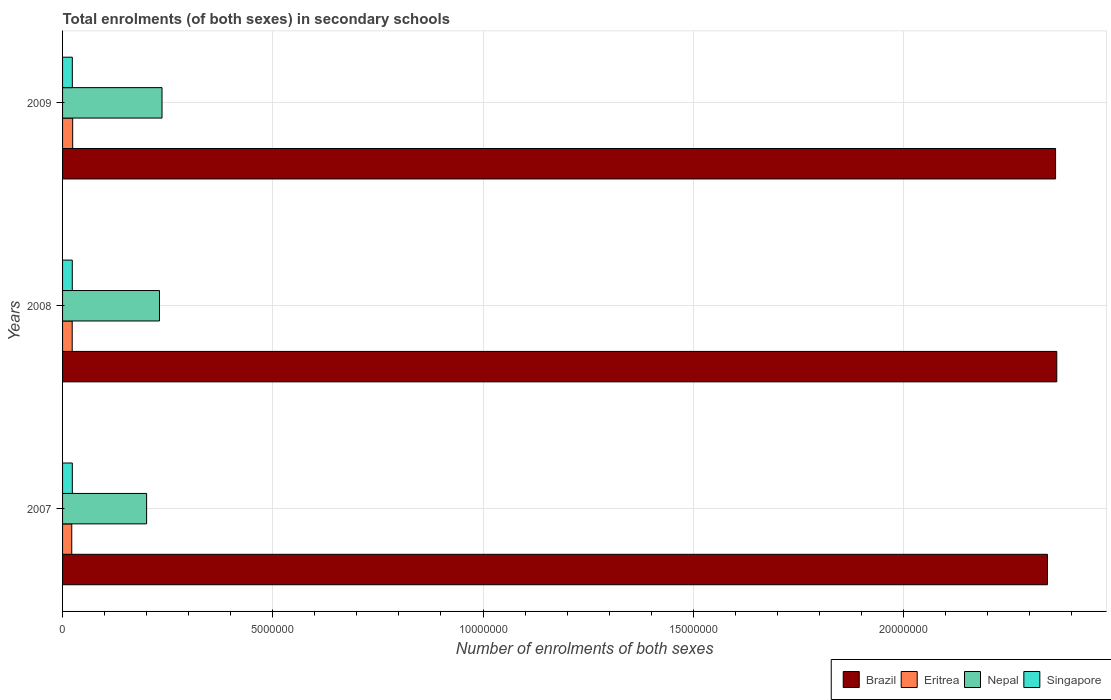How many different coloured bars are there?
Ensure brevity in your answer.  4. How many groups of bars are there?
Provide a succinct answer. 3. Are the number of bars on each tick of the Y-axis equal?
Offer a very short reply. Yes. How many bars are there on the 3rd tick from the top?
Make the answer very short. 4. What is the number of enrolments in secondary schools in Brazil in 2009?
Ensure brevity in your answer.  2.36e+07. Across all years, what is the maximum number of enrolments in secondary schools in Eritrea?
Offer a very short reply. 2.41e+05. Across all years, what is the minimum number of enrolments in secondary schools in Eritrea?
Offer a very short reply. 2.18e+05. In which year was the number of enrolments in secondary schools in Nepal maximum?
Your answer should be very brief. 2009. What is the total number of enrolments in secondary schools in Brazil in the graph?
Provide a short and direct response. 7.07e+07. What is the difference between the number of enrolments in secondary schools in Eritrea in 2008 and that in 2009?
Ensure brevity in your answer.  -1.18e+04. What is the difference between the number of enrolments in secondary schools in Brazil in 2009 and the number of enrolments in secondary schools in Singapore in 2008?
Give a very brief answer. 2.34e+07. What is the average number of enrolments in secondary schools in Singapore per year?
Your response must be concise. 2.32e+05. In the year 2009, what is the difference between the number of enrolments in secondary schools in Nepal and number of enrolments in secondary schools in Brazil?
Ensure brevity in your answer.  -2.13e+07. In how many years, is the number of enrolments in secondary schools in Eritrea greater than 6000000 ?
Make the answer very short. 0. What is the ratio of the number of enrolments in secondary schools in Eritrea in 2007 to that in 2009?
Your answer should be very brief. 0.91. Is the number of enrolments in secondary schools in Brazil in 2007 less than that in 2009?
Provide a succinct answer. Yes. Is the difference between the number of enrolments in secondary schools in Nepal in 2007 and 2008 greater than the difference between the number of enrolments in secondary schools in Brazil in 2007 and 2008?
Give a very brief answer. No. What is the difference between the highest and the second highest number of enrolments in secondary schools in Brazil?
Keep it short and to the point. 2.87e+04. What is the difference between the highest and the lowest number of enrolments in secondary schools in Eritrea?
Offer a terse response. 2.25e+04. Is it the case that in every year, the sum of the number of enrolments in secondary schools in Eritrea and number of enrolments in secondary schools in Brazil is greater than the sum of number of enrolments in secondary schools in Singapore and number of enrolments in secondary schools in Nepal?
Provide a succinct answer. No. What does the 2nd bar from the top in 2007 represents?
Keep it short and to the point. Nepal. What does the 3rd bar from the bottom in 2009 represents?
Ensure brevity in your answer.  Nepal. How many bars are there?
Your response must be concise. 12. Are all the bars in the graph horizontal?
Make the answer very short. Yes. Does the graph contain any zero values?
Provide a succinct answer. No. How many legend labels are there?
Offer a terse response. 4. How are the legend labels stacked?
Give a very brief answer. Horizontal. What is the title of the graph?
Your response must be concise. Total enrolments (of both sexes) in secondary schools. Does "Serbia" appear as one of the legend labels in the graph?
Offer a terse response. No. What is the label or title of the X-axis?
Provide a short and direct response. Number of enrolments of both sexes. What is the label or title of the Y-axis?
Provide a short and direct response. Years. What is the Number of enrolments of both sexes of Brazil in 2007?
Offer a terse response. 2.34e+07. What is the Number of enrolments of both sexes of Eritrea in 2007?
Provide a succinct answer. 2.18e+05. What is the Number of enrolments of both sexes of Nepal in 2007?
Provide a short and direct response. 2.00e+06. What is the Number of enrolments of both sexes in Singapore in 2007?
Provide a succinct answer. 2.32e+05. What is the Number of enrolments of both sexes of Brazil in 2008?
Keep it short and to the point. 2.36e+07. What is the Number of enrolments of both sexes of Eritrea in 2008?
Keep it short and to the point. 2.29e+05. What is the Number of enrolments of both sexes in Nepal in 2008?
Give a very brief answer. 2.31e+06. What is the Number of enrolments of both sexes of Singapore in 2008?
Your answer should be very brief. 2.31e+05. What is the Number of enrolments of both sexes of Brazil in 2009?
Ensure brevity in your answer.  2.36e+07. What is the Number of enrolments of both sexes in Eritrea in 2009?
Your response must be concise. 2.41e+05. What is the Number of enrolments of both sexes of Nepal in 2009?
Offer a very short reply. 2.37e+06. What is the Number of enrolments of both sexes of Singapore in 2009?
Give a very brief answer. 2.32e+05. Across all years, what is the maximum Number of enrolments of both sexes in Brazil?
Ensure brevity in your answer.  2.36e+07. Across all years, what is the maximum Number of enrolments of both sexes in Eritrea?
Your answer should be very brief. 2.41e+05. Across all years, what is the maximum Number of enrolments of both sexes in Nepal?
Provide a short and direct response. 2.37e+06. Across all years, what is the maximum Number of enrolments of both sexes in Singapore?
Offer a terse response. 2.32e+05. Across all years, what is the minimum Number of enrolments of both sexes in Brazil?
Your answer should be very brief. 2.34e+07. Across all years, what is the minimum Number of enrolments of both sexes in Eritrea?
Keep it short and to the point. 2.18e+05. Across all years, what is the minimum Number of enrolments of both sexes of Nepal?
Ensure brevity in your answer.  2.00e+06. Across all years, what is the minimum Number of enrolments of both sexes in Singapore?
Your response must be concise. 2.31e+05. What is the total Number of enrolments of both sexes of Brazil in the graph?
Keep it short and to the point. 7.07e+07. What is the total Number of enrolments of both sexes of Eritrea in the graph?
Your response must be concise. 6.88e+05. What is the total Number of enrolments of both sexes of Nepal in the graph?
Provide a short and direct response. 6.67e+06. What is the total Number of enrolments of both sexes in Singapore in the graph?
Offer a very short reply. 6.95e+05. What is the difference between the Number of enrolments of both sexes of Brazil in 2007 and that in 2008?
Offer a terse response. -2.22e+05. What is the difference between the Number of enrolments of both sexes in Eritrea in 2007 and that in 2008?
Your answer should be compact. -1.07e+04. What is the difference between the Number of enrolments of both sexes in Nepal in 2007 and that in 2008?
Your response must be concise. -3.06e+05. What is the difference between the Number of enrolments of both sexes in Singapore in 2007 and that in 2008?
Keep it short and to the point. 956. What is the difference between the Number of enrolments of both sexes in Brazil in 2007 and that in 2009?
Offer a terse response. -1.93e+05. What is the difference between the Number of enrolments of both sexes of Eritrea in 2007 and that in 2009?
Your answer should be very brief. -2.25e+04. What is the difference between the Number of enrolments of both sexes of Nepal in 2007 and that in 2009?
Give a very brief answer. -3.66e+05. What is the difference between the Number of enrolments of both sexes of Singapore in 2007 and that in 2009?
Provide a short and direct response. 97. What is the difference between the Number of enrolments of both sexes in Brazil in 2008 and that in 2009?
Give a very brief answer. 2.87e+04. What is the difference between the Number of enrolments of both sexes of Eritrea in 2008 and that in 2009?
Your answer should be very brief. -1.18e+04. What is the difference between the Number of enrolments of both sexes of Nepal in 2008 and that in 2009?
Your response must be concise. -6.01e+04. What is the difference between the Number of enrolments of both sexes in Singapore in 2008 and that in 2009?
Give a very brief answer. -859. What is the difference between the Number of enrolments of both sexes of Brazil in 2007 and the Number of enrolments of both sexes of Eritrea in 2008?
Offer a very short reply. 2.32e+07. What is the difference between the Number of enrolments of both sexes of Brazil in 2007 and the Number of enrolments of both sexes of Nepal in 2008?
Provide a short and direct response. 2.11e+07. What is the difference between the Number of enrolments of both sexes of Brazil in 2007 and the Number of enrolments of both sexes of Singapore in 2008?
Make the answer very short. 2.32e+07. What is the difference between the Number of enrolments of both sexes of Eritrea in 2007 and the Number of enrolments of both sexes of Nepal in 2008?
Provide a succinct answer. -2.09e+06. What is the difference between the Number of enrolments of both sexes of Eritrea in 2007 and the Number of enrolments of both sexes of Singapore in 2008?
Your response must be concise. -1.28e+04. What is the difference between the Number of enrolments of both sexes in Nepal in 2007 and the Number of enrolments of both sexes in Singapore in 2008?
Provide a short and direct response. 1.77e+06. What is the difference between the Number of enrolments of both sexes in Brazil in 2007 and the Number of enrolments of both sexes in Eritrea in 2009?
Make the answer very short. 2.32e+07. What is the difference between the Number of enrolments of both sexes in Brazil in 2007 and the Number of enrolments of both sexes in Nepal in 2009?
Your response must be concise. 2.11e+07. What is the difference between the Number of enrolments of both sexes of Brazil in 2007 and the Number of enrolments of both sexes of Singapore in 2009?
Provide a short and direct response. 2.32e+07. What is the difference between the Number of enrolments of both sexes of Eritrea in 2007 and the Number of enrolments of both sexes of Nepal in 2009?
Your answer should be compact. -2.15e+06. What is the difference between the Number of enrolments of both sexes of Eritrea in 2007 and the Number of enrolments of both sexes of Singapore in 2009?
Your response must be concise. -1.36e+04. What is the difference between the Number of enrolments of both sexes in Nepal in 2007 and the Number of enrolments of both sexes in Singapore in 2009?
Give a very brief answer. 1.77e+06. What is the difference between the Number of enrolments of both sexes in Brazil in 2008 and the Number of enrolments of both sexes in Eritrea in 2009?
Provide a short and direct response. 2.34e+07. What is the difference between the Number of enrolments of both sexes of Brazil in 2008 and the Number of enrolments of both sexes of Nepal in 2009?
Make the answer very short. 2.13e+07. What is the difference between the Number of enrolments of both sexes in Brazil in 2008 and the Number of enrolments of both sexes in Singapore in 2009?
Offer a terse response. 2.34e+07. What is the difference between the Number of enrolments of both sexes in Eritrea in 2008 and the Number of enrolments of both sexes in Nepal in 2009?
Give a very brief answer. -2.14e+06. What is the difference between the Number of enrolments of both sexes of Eritrea in 2008 and the Number of enrolments of both sexes of Singapore in 2009?
Provide a short and direct response. -2924. What is the difference between the Number of enrolments of both sexes in Nepal in 2008 and the Number of enrolments of both sexes in Singapore in 2009?
Offer a terse response. 2.07e+06. What is the average Number of enrolments of both sexes of Brazil per year?
Your answer should be very brief. 2.36e+07. What is the average Number of enrolments of both sexes of Eritrea per year?
Ensure brevity in your answer.  2.29e+05. What is the average Number of enrolments of both sexes in Nepal per year?
Provide a short and direct response. 2.22e+06. What is the average Number of enrolments of both sexes in Singapore per year?
Make the answer very short. 2.32e+05. In the year 2007, what is the difference between the Number of enrolments of both sexes in Brazil and Number of enrolments of both sexes in Eritrea?
Provide a short and direct response. 2.32e+07. In the year 2007, what is the difference between the Number of enrolments of both sexes in Brazil and Number of enrolments of both sexes in Nepal?
Your answer should be very brief. 2.14e+07. In the year 2007, what is the difference between the Number of enrolments of both sexes of Brazil and Number of enrolments of both sexes of Singapore?
Provide a succinct answer. 2.32e+07. In the year 2007, what is the difference between the Number of enrolments of both sexes of Eritrea and Number of enrolments of both sexes of Nepal?
Provide a succinct answer. -1.78e+06. In the year 2007, what is the difference between the Number of enrolments of both sexes of Eritrea and Number of enrolments of both sexes of Singapore?
Your response must be concise. -1.37e+04. In the year 2007, what is the difference between the Number of enrolments of both sexes in Nepal and Number of enrolments of both sexes in Singapore?
Give a very brief answer. 1.77e+06. In the year 2008, what is the difference between the Number of enrolments of both sexes of Brazil and Number of enrolments of both sexes of Eritrea?
Give a very brief answer. 2.34e+07. In the year 2008, what is the difference between the Number of enrolments of both sexes of Brazil and Number of enrolments of both sexes of Nepal?
Offer a terse response. 2.13e+07. In the year 2008, what is the difference between the Number of enrolments of both sexes of Brazil and Number of enrolments of both sexes of Singapore?
Ensure brevity in your answer.  2.34e+07. In the year 2008, what is the difference between the Number of enrolments of both sexes of Eritrea and Number of enrolments of both sexes of Nepal?
Ensure brevity in your answer.  -2.08e+06. In the year 2008, what is the difference between the Number of enrolments of both sexes in Eritrea and Number of enrolments of both sexes in Singapore?
Your answer should be very brief. -2065. In the year 2008, what is the difference between the Number of enrolments of both sexes in Nepal and Number of enrolments of both sexes in Singapore?
Provide a short and direct response. 2.07e+06. In the year 2009, what is the difference between the Number of enrolments of both sexes of Brazil and Number of enrolments of both sexes of Eritrea?
Provide a succinct answer. 2.34e+07. In the year 2009, what is the difference between the Number of enrolments of both sexes of Brazil and Number of enrolments of both sexes of Nepal?
Give a very brief answer. 2.13e+07. In the year 2009, what is the difference between the Number of enrolments of both sexes in Brazil and Number of enrolments of both sexes in Singapore?
Provide a succinct answer. 2.34e+07. In the year 2009, what is the difference between the Number of enrolments of both sexes in Eritrea and Number of enrolments of both sexes in Nepal?
Give a very brief answer. -2.12e+06. In the year 2009, what is the difference between the Number of enrolments of both sexes in Eritrea and Number of enrolments of both sexes in Singapore?
Offer a very short reply. 8889. In the year 2009, what is the difference between the Number of enrolments of both sexes of Nepal and Number of enrolments of both sexes of Singapore?
Your answer should be very brief. 2.13e+06. What is the ratio of the Number of enrolments of both sexes of Brazil in 2007 to that in 2008?
Your answer should be very brief. 0.99. What is the ratio of the Number of enrolments of both sexes in Eritrea in 2007 to that in 2008?
Provide a succinct answer. 0.95. What is the ratio of the Number of enrolments of both sexes of Nepal in 2007 to that in 2008?
Your answer should be very brief. 0.87. What is the ratio of the Number of enrolments of both sexes in Eritrea in 2007 to that in 2009?
Your answer should be very brief. 0.91. What is the ratio of the Number of enrolments of both sexes in Nepal in 2007 to that in 2009?
Your answer should be very brief. 0.85. What is the ratio of the Number of enrolments of both sexes of Brazil in 2008 to that in 2009?
Your answer should be compact. 1. What is the ratio of the Number of enrolments of both sexes of Eritrea in 2008 to that in 2009?
Give a very brief answer. 0.95. What is the ratio of the Number of enrolments of both sexes of Nepal in 2008 to that in 2009?
Offer a very short reply. 0.97. What is the ratio of the Number of enrolments of both sexes of Singapore in 2008 to that in 2009?
Provide a succinct answer. 1. What is the difference between the highest and the second highest Number of enrolments of both sexes in Brazil?
Your answer should be very brief. 2.87e+04. What is the difference between the highest and the second highest Number of enrolments of both sexes in Eritrea?
Offer a terse response. 1.18e+04. What is the difference between the highest and the second highest Number of enrolments of both sexes of Nepal?
Offer a very short reply. 6.01e+04. What is the difference between the highest and the second highest Number of enrolments of both sexes of Singapore?
Offer a terse response. 97. What is the difference between the highest and the lowest Number of enrolments of both sexes of Brazil?
Make the answer very short. 2.22e+05. What is the difference between the highest and the lowest Number of enrolments of both sexes of Eritrea?
Provide a short and direct response. 2.25e+04. What is the difference between the highest and the lowest Number of enrolments of both sexes in Nepal?
Your answer should be compact. 3.66e+05. What is the difference between the highest and the lowest Number of enrolments of both sexes of Singapore?
Your answer should be compact. 956. 